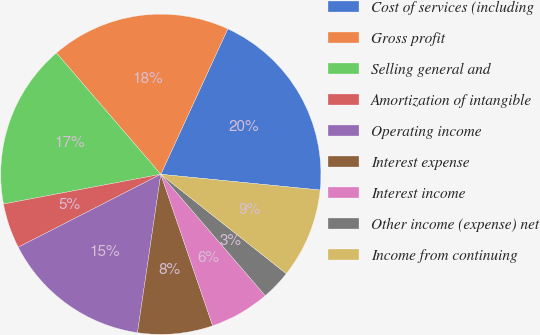Convert chart to OTSL. <chart><loc_0><loc_0><loc_500><loc_500><pie_chart><fcel>Cost of services (including<fcel>Gross profit<fcel>Selling general and<fcel>Amortization of intangible<fcel>Operating income<fcel>Interest expense<fcel>Interest income<fcel>Other income (expense) net<fcel>Income from continuing<nl><fcel>19.7%<fcel>18.18%<fcel>16.67%<fcel>4.55%<fcel>15.15%<fcel>7.58%<fcel>6.06%<fcel>3.03%<fcel>9.09%<nl></chart> 